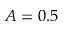Convert formula to latex. <formula><loc_0><loc_0><loc_500><loc_500>A = 0 . 5</formula> 